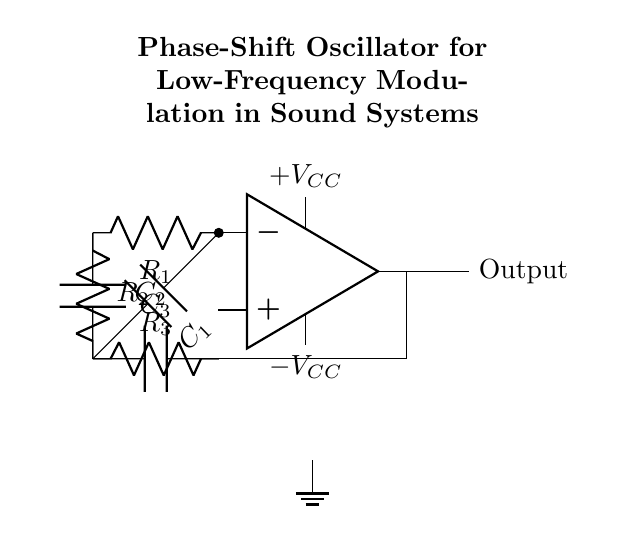What type of components are predominantly used in this circuit? The circuit primarily comprises operational amplifiers, resistors, and capacitors. These components are used to create the phase shift necessary for oscillation.
Answer: operational amplifiers, resistors, capacitors How many resistors are present in the circuit? The circuit diagram shows three resistors labeled R1, R2, and R3. Hence, the total number of resistors is three.
Answer: three What is the role of capacitors in this oscillator circuit? Capacitors in this circuit are used to create the necessary phase shift for the oscillation. Each capacitor works with the resistors to establish feedback that generates a stable oscillation.
Answer: phase shift Which component provides the output of the oscillator? The output of the oscillator is taken directly from the operational amplifier, which is indicated as Out in the diagram.
Answer: operational amplifier What feedback mechanism is utilized in this phase-shift oscillator? The feedback mechanism in this oscillator is positive feedback, where the output of the operational amplifier is connected back to a point in the circuit, specifically to the resistors, promoting oscillation.
Answer: positive feedback How does the configuration of R1, R2, and R3 influence oscillation frequency? The arrangement and values of R1, R2, and R3, in conjunction with the capacitors, determine the timing characteristics of the phase shift oscillator, ultimately affecting the frequency of oscillation. This is a common property in oscillator circuits.
Answer: influences frequency What is the significance of the voltage supply in this circuit? The voltage supply, which includes both positive and negative supply voltages, provides the power necessary for the operational amplifier to function and generate the oscillations. Without it, the circuit would not operate.
Answer: power supply 